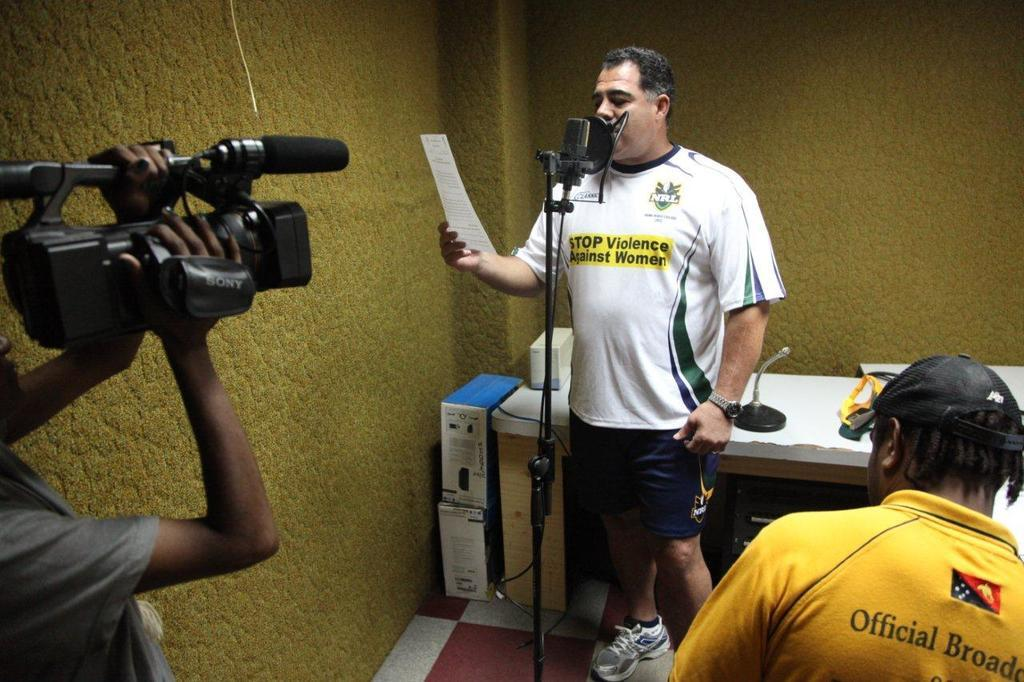<image>
Write a terse but informative summary of the picture. A man is holding a piece of paper and talking into a mic and his shirt says Stop Violence Against Women. 